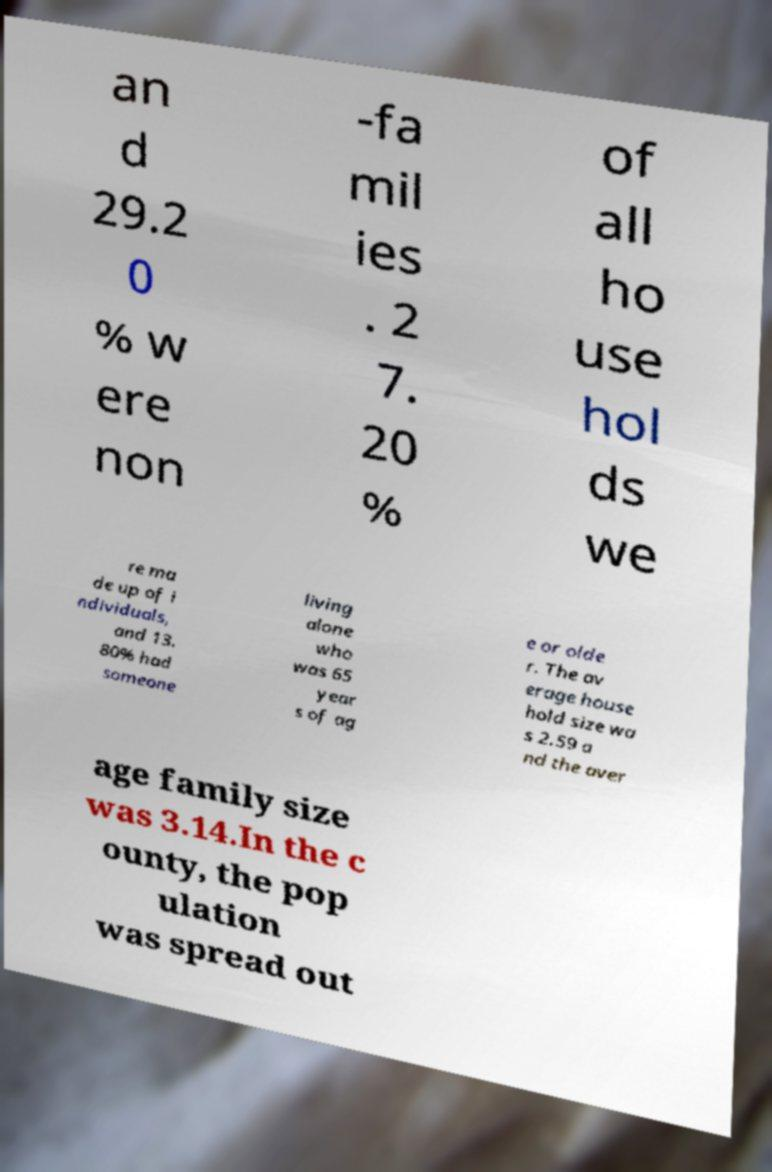Can you read and provide the text displayed in the image?This photo seems to have some interesting text. Can you extract and type it out for me? an d 29.2 0 % w ere non -fa mil ies . 2 7. 20 % of all ho use hol ds we re ma de up of i ndividuals, and 13. 80% had someone living alone who was 65 year s of ag e or olde r. The av erage house hold size wa s 2.59 a nd the aver age family size was 3.14.In the c ounty, the pop ulation was spread out 